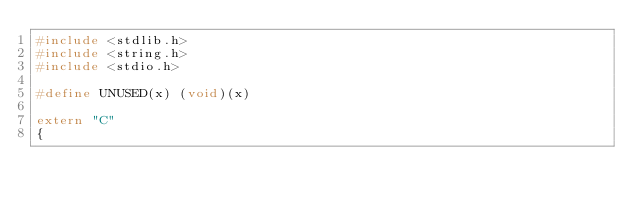Convert code to text. <code><loc_0><loc_0><loc_500><loc_500><_C++_>#include <stdlib.h>
#include <string.h>
#include <stdio.h>

#define UNUSED(x) (void)(x)

extern "C"
{</code> 